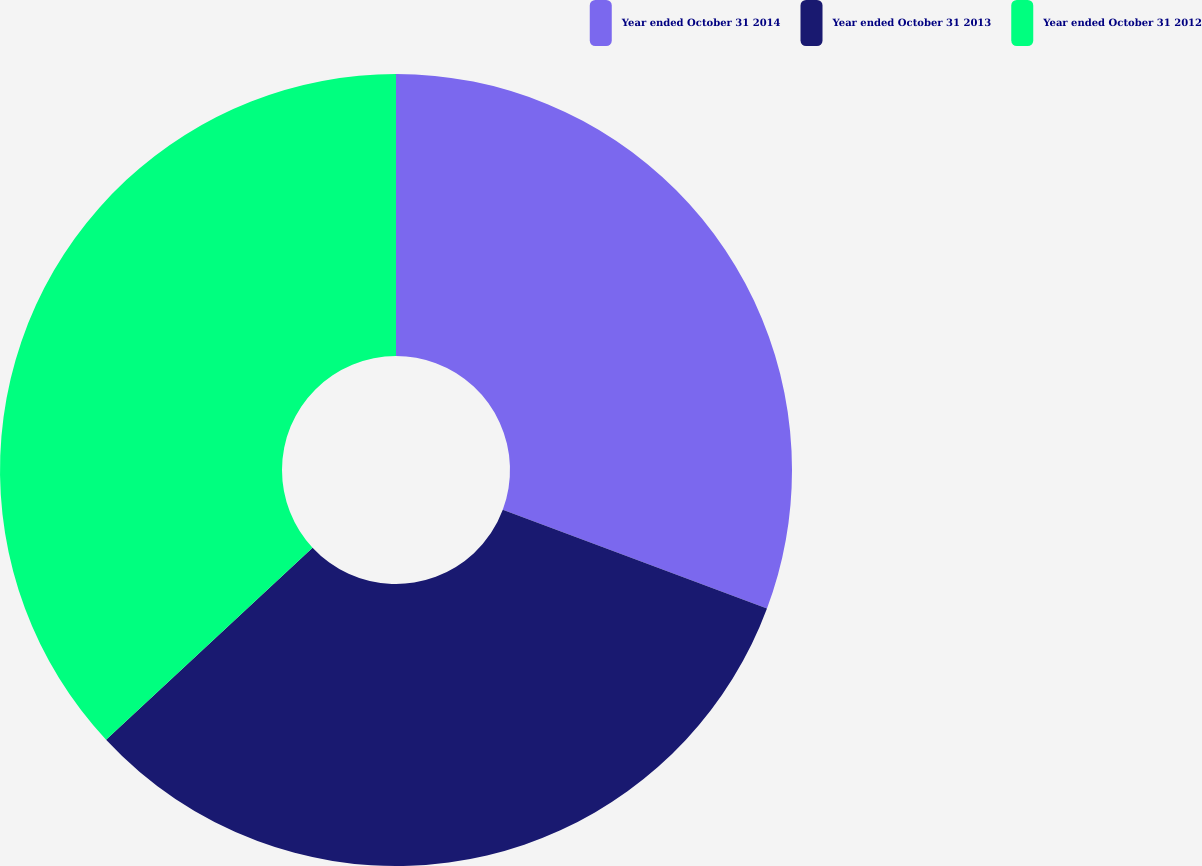Convert chart to OTSL. <chart><loc_0><loc_0><loc_500><loc_500><pie_chart><fcel>Year ended October 31 2014<fcel>Year ended October 31 2013<fcel>Year ended October 31 2012<nl><fcel>30.69%<fcel>32.39%<fcel>36.93%<nl></chart> 